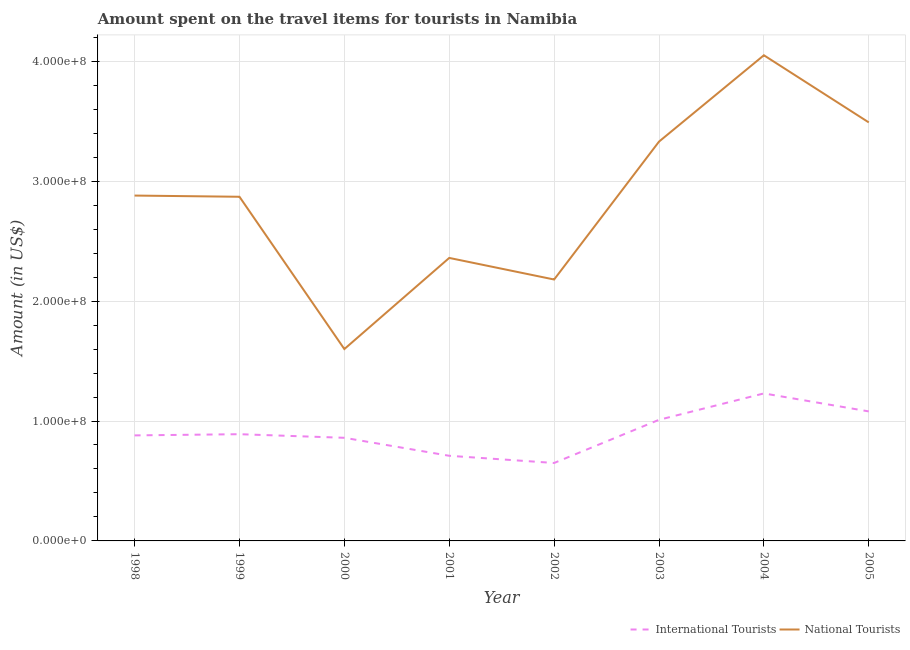How many different coloured lines are there?
Ensure brevity in your answer.  2. Does the line corresponding to amount spent on travel items of national tourists intersect with the line corresponding to amount spent on travel items of international tourists?
Make the answer very short. No. Is the number of lines equal to the number of legend labels?
Give a very brief answer. Yes. What is the amount spent on travel items of national tourists in 2004?
Provide a short and direct response. 4.05e+08. Across all years, what is the maximum amount spent on travel items of national tourists?
Keep it short and to the point. 4.05e+08. Across all years, what is the minimum amount spent on travel items of international tourists?
Keep it short and to the point. 6.50e+07. In which year was the amount spent on travel items of international tourists minimum?
Offer a very short reply. 2002. What is the total amount spent on travel items of international tourists in the graph?
Give a very brief answer. 7.31e+08. What is the difference between the amount spent on travel items of international tourists in 1999 and that in 2001?
Your answer should be very brief. 1.80e+07. What is the difference between the amount spent on travel items of international tourists in 2003 and the amount spent on travel items of national tourists in 2004?
Make the answer very short. -3.04e+08. What is the average amount spent on travel items of international tourists per year?
Keep it short and to the point. 9.14e+07. In the year 1998, what is the difference between the amount spent on travel items of national tourists and amount spent on travel items of international tourists?
Offer a terse response. 2.00e+08. In how many years, is the amount spent on travel items of national tourists greater than 40000000 US$?
Offer a terse response. 8. What is the ratio of the amount spent on travel items of international tourists in 2001 to that in 2002?
Your response must be concise. 1.09. Is the amount spent on travel items of international tourists in 2002 less than that in 2004?
Provide a succinct answer. Yes. What is the difference between the highest and the second highest amount spent on travel items of national tourists?
Provide a succinct answer. 5.60e+07. What is the difference between the highest and the lowest amount spent on travel items of national tourists?
Offer a terse response. 2.45e+08. In how many years, is the amount spent on travel items of international tourists greater than the average amount spent on travel items of international tourists taken over all years?
Keep it short and to the point. 3. Is the amount spent on travel items of national tourists strictly greater than the amount spent on travel items of international tourists over the years?
Provide a succinct answer. Yes. Is the amount spent on travel items of international tourists strictly less than the amount spent on travel items of national tourists over the years?
Offer a very short reply. Yes. How many years are there in the graph?
Keep it short and to the point. 8. What is the difference between two consecutive major ticks on the Y-axis?
Offer a terse response. 1.00e+08. How many legend labels are there?
Make the answer very short. 2. What is the title of the graph?
Keep it short and to the point. Amount spent on the travel items for tourists in Namibia. Does "Girls" appear as one of the legend labels in the graph?
Your answer should be compact. No. What is the label or title of the X-axis?
Your answer should be compact. Year. What is the Amount (in US$) in International Tourists in 1998?
Offer a very short reply. 8.80e+07. What is the Amount (in US$) in National Tourists in 1998?
Your response must be concise. 2.88e+08. What is the Amount (in US$) of International Tourists in 1999?
Provide a succinct answer. 8.90e+07. What is the Amount (in US$) in National Tourists in 1999?
Your answer should be compact. 2.87e+08. What is the Amount (in US$) of International Tourists in 2000?
Provide a short and direct response. 8.60e+07. What is the Amount (in US$) of National Tourists in 2000?
Your answer should be compact. 1.60e+08. What is the Amount (in US$) in International Tourists in 2001?
Your response must be concise. 7.10e+07. What is the Amount (in US$) in National Tourists in 2001?
Your response must be concise. 2.36e+08. What is the Amount (in US$) in International Tourists in 2002?
Offer a very short reply. 6.50e+07. What is the Amount (in US$) in National Tourists in 2002?
Your response must be concise. 2.18e+08. What is the Amount (in US$) in International Tourists in 2003?
Offer a very short reply. 1.01e+08. What is the Amount (in US$) in National Tourists in 2003?
Offer a very short reply. 3.33e+08. What is the Amount (in US$) in International Tourists in 2004?
Ensure brevity in your answer.  1.23e+08. What is the Amount (in US$) in National Tourists in 2004?
Keep it short and to the point. 4.05e+08. What is the Amount (in US$) of International Tourists in 2005?
Your response must be concise. 1.08e+08. What is the Amount (in US$) of National Tourists in 2005?
Offer a very short reply. 3.49e+08. Across all years, what is the maximum Amount (in US$) of International Tourists?
Provide a succinct answer. 1.23e+08. Across all years, what is the maximum Amount (in US$) of National Tourists?
Make the answer very short. 4.05e+08. Across all years, what is the minimum Amount (in US$) in International Tourists?
Your answer should be compact. 6.50e+07. Across all years, what is the minimum Amount (in US$) in National Tourists?
Make the answer very short. 1.60e+08. What is the total Amount (in US$) of International Tourists in the graph?
Offer a very short reply. 7.31e+08. What is the total Amount (in US$) of National Tourists in the graph?
Your response must be concise. 2.28e+09. What is the difference between the Amount (in US$) in International Tourists in 1998 and that in 2000?
Keep it short and to the point. 2.00e+06. What is the difference between the Amount (in US$) of National Tourists in 1998 and that in 2000?
Ensure brevity in your answer.  1.28e+08. What is the difference between the Amount (in US$) of International Tourists in 1998 and that in 2001?
Keep it short and to the point. 1.70e+07. What is the difference between the Amount (in US$) of National Tourists in 1998 and that in 2001?
Keep it short and to the point. 5.20e+07. What is the difference between the Amount (in US$) of International Tourists in 1998 and that in 2002?
Ensure brevity in your answer.  2.30e+07. What is the difference between the Amount (in US$) in National Tourists in 1998 and that in 2002?
Provide a succinct answer. 7.00e+07. What is the difference between the Amount (in US$) of International Tourists in 1998 and that in 2003?
Give a very brief answer. -1.30e+07. What is the difference between the Amount (in US$) of National Tourists in 1998 and that in 2003?
Your answer should be compact. -4.50e+07. What is the difference between the Amount (in US$) in International Tourists in 1998 and that in 2004?
Ensure brevity in your answer.  -3.50e+07. What is the difference between the Amount (in US$) of National Tourists in 1998 and that in 2004?
Offer a terse response. -1.17e+08. What is the difference between the Amount (in US$) of International Tourists in 1998 and that in 2005?
Your answer should be compact. -2.00e+07. What is the difference between the Amount (in US$) in National Tourists in 1998 and that in 2005?
Make the answer very short. -6.10e+07. What is the difference between the Amount (in US$) of International Tourists in 1999 and that in 2000?
Your answer should be compact. 3.00e+06. What is the difference between the Amount (in US$) in National Tourists in 1999 and that in 2000?
Provide a short and direct response. 1.27e+08. What is the difference between the Amount (in US$) in International Tourists in 1999 and that in 2001?
Provide a succinct answer. 1.80e+07. What is the difference between the Amount (in US$) in National Tourists in 1999 and that in 2001?
Make the answer very short. 5.10e+07. What is the difference between the Amount (in US$) in International Tourists in 1999 and that in 2002?
Keep it short and to the point. 2.40e+07. What is the difference between the Amount (in US$) in National Tourists in 1999 and that in 2002?
Give a very brief answer. 6.90e+07. What is the difference between the Amount (in US$) of International Tourists in 1999 and that in 2003?
Your answer should be very brief. -1.20e+07. What is the difference between the Amount (in US$) of National Tourists in 1999 and that in 2003?
Your response must be concise. -4.60e+07. What is the difference between the Amount (in US$) of International Tourists in 1999 and that in 2004?
Ensure brevity in your answer.  -3.40e+07. What is the difference between the Amount (in US$) of National Tourists in 1999 and that in 2004?
Ensure brevity in your answer.  -1.18e+08. What is the difference between the Amount (in US$) in International Tourists in 1999 and that in 2005?
Provide a succinct answer. -1.90e+07. What is the difference between the Amount (in US$) of National Tourists in 1999 and that in 2005?
Your response must be concise. -6.20e+07. What is the difference between the Amount (in US$) of International Tourists in 2000 and that in 2001?
Your answer should be compact. 1.50e+07. What is the difference between the Amount (in US$) in National Tourists in 2000 and that in 2001?
Keep it short and to the point. -7.60e+07. What is the difference between the Amount (in US$) in International Tourists in 2000 and that in 2002?
Your response must be concise. 2.10e+07. What is the difference between the Amount (in US$) of National Tourists in 2000 and that in 2002?
Keep it short and to the point. -5.80e+07. What is the difference between the Amount (in US$) in International Tourists in 2000 and that in 2003?
Give a very brief answer. -1.50e+07. What is the difference between the Amount (in US$) in National Tourists in 2000 and that in 2003?
Give a very brief answer. -1.73e+08. What is the difference between the Amount (in US$) of International Tourists in 2000 and that in 2004?
Keep it short and to the point. -3.70e+07. What is the difference between the Amount (in US$) in National Tourists in 2000 and that in 2004?
Keep it short and to the point. -2.45e+08. What is the difference between the Amount (in US$) in International Tourists in 2000 and that in 2005?
Give a very brief answer. -2.20e+07. What is the difference between the Amount (in US$) in National Tourists in 2000 and that in 2005?
Your answer should be compact. -1.89e+08. What is the difference between the Amount (in US$) in National Tourists in 2001 and that in 2002?
Offer a very short reply. 1.80e+07. What is the difference between the Amount (in US$) in International Tourists in 2001 and that in 2003?
Your answer should be very brief. -3.00e+07. What is the difference between the Amount (in US$) in National Tourists in 2001 and that in 2003?
Keep it short and to the point. -9.70e+07. What is the difference between the Amount (in US$) of International Tourists in 2001 and that in 2004?
Keep it short and to the point. -5.20e+07. What is the difference between the Amount (in US$) of National Tourists in 2001 and that in 2004?
Your answer should be very brief. -1.69e+08. What is the difference between the Amount (in US$) of International Tourists in 2001 and that in 2005?
Provide a succinct answer. -3.70e+07. What is the difference between the Amount (in US$) of National Tourists in 2001 and that in 2005?
Your answer should be very brief. -1.13e+08. What is the difference between the Amount (in US$) of International Tourists in 2002 and that in 2003?
Ensure brevity in your answer.  -3.60e+07. What is the difference between the Amount (in US$) in National Tourists in 2002 and that in 2003?
Your answer should be compact. -1.15e+08. What is the difference between the Amount (in US$) of International Tourists in 2002 and that in 2004?
Ensure brevity in your answer.  -5.80e+07. What is the difference between the Amount (in US$) in National Tourists in 2002 and that in 2004?
Ensure brevity in your answer.  -1.87e+08. What is the difference between the Amount (in US$) of International Tourists in 2002 and that in 2005?
Your answer should be very brief. -4.30e+07. What is the difference between the Amount (in US$) in National Tourists in 2002 and that in 2005?
Give a very brief answer. -1.31e+08. What is the difference between the Amount (in US$) in International Tourists in 2003 and that in 2004?
Provide a succinct answer. -2.20e+07. What is the difference between the Amount (in US$) in National Tourists in 2003 and that in 2004?
Your answer should be very brief. -7.20e+07. What is the difference between the Amount (in US$) of International Tourists in 2003 and that in 2005?
Keep it short and to the point. -7.00e+06. What is the difference between the Amount (in US$) in National Tourists in 2003 and that in 2005?
Provide a short and direct response. -1.60e+07. What is the difference between the Amount (in US$) in International Tourists in 2004 and that in 2005?
Provide a succinct answer. 1.50e+07. What is the difference between the Amount (in US$) in National Tourists in 2004 and that in 2005?
Give a very brief answer. 5.60e+07. What is the difference between the Amount (in US$) in International Tourists in 1998 and the Amount (in US$) in National Tourists in 1999?
Ensure brevity in your answer.  -1.99e+08. What is the difference between the Amount (in US$) in International Tourists in 1998 and the Amount (in US$) in National Tourists in 2000?
Provide a short and direct response. -7.20e+07. What is the difference between the Amount (in US$) of International Tourists in 1998 and the Amount (in US$) of National Tourists in 2001?
Your answer should be very brief. -1.48e+08. What is the difference between the Amount (in US$) of International Tourists in 1998 and the Amount (in US$) of National Tourists in 2002?
Provide a succinct answer. -1.30e+08. What is the difference between the Amount (in US$) of International Tourists in 1998 and the Amount (in US$) of National Tourists in 2003?
Offer a very short reply. -2.45e+08. What is the difference between the Amount (in US$) of International Tourists in 1998 and the Amount (in US$) of National Tourists in 2004?
Give a very brief answer. -3.17e+08. What is the difference between the Amount (in US$) in International Tourists in 1998 and the Amount (in US$) in National Tourists in 2005?
Ensure brevity in your answer.  -2.61e+08. What is the difference between the Amount (in US$) of International Tourists in 1999 and the Amount (in US$) of National Tourists in 2000?
Provide a succinct answer. -7.10e+07. What is the difference between the Amount (in US$) in International Tourists in 1999 and the Amount (in US$) in National Tourists in 2001?
Provide a succinct answer. -1.47e+08. What is the difference between the Amount (in US$) of International Tourists in 1999 and the Amount (in US$) of National Tourists in 2002?
Offer a very short reply. -1.29e+08. What is the difference between the Amount (in US$) in International Tourists in 1999 and the Amount (in US$) in National Tourists in 2003?
Ensure brevity in your answer.  -2.44e+08. What is the difference between the Amount (in US$) of International Tourists in 1999 and the Amount (in US$) of National Tourists in 2004?
Keep it short and to the point. -3.16e+08. What is the difference between the Amount (in US$) in International Tourists in 1999 and the Amount (in US$) in National Tourists in 2005?
Your answer should be very brief. -2.60e+08. What is the difference between the Amount (in US$) of International Tourists in 2000 and the Amount (in US$) of National Tourists in 2001?
Your answer should be compact. -1.50e+08. What is the difference between the Amount (in US$) in International Tourists in 2000 and the Amount (in US$) in National Tourists in 2002?
Make the answer very short. -1.32e+08. What is the difference between the Amount (in US$) of International Tourists in 2000 and the Amount (in US$) of National Tourists in 2003?
Provide a succinct answer. -2.47e+08. What is the difference between the Amount (in US$) of International Tourists in 2000 and the Amount (in US$) of National Tourists in 2004?
Keep it short and to the point. -3.19e+08. What is the difference between the Amount (in US$) in International Tourists in 2000 and the Amount (in US$) in National Tourists in 2005?
Provide a short and direct response. -2.63e+08. What is the difference between the Amount (in US$) in International Tourists in 2001 and the Amount (in US$) in National Tourists in 2002?
Give a very brief answer. -1.47e+08. What is the difference between the Amount (in US$) of International Tourists in 2001 and the Amount (in US$) of National Tourists in 2003?
Offer a very short reply. -2.62e+08. What is the difference between the Amount (in US$) in International Tourists in 2001 and the Amount (in US$) in National Tourists in 2004?
Your answer should be compact. -3.34e+08. What is the difference between the Amount (in US$) of International Tourists in 2001 and the Amount (in US$) of National Tourists in 2005?
Offer a terse response. -2.78e+08. What is the difference between the Amount (in US$) in International Tourists in 2002 and the Amount (in US$) in National Tourists in 2003?
Your answer should be very brief. -2.68e+08. What is the difference between the Amount (in US$) of International Tourists in 2002 and the Amount (in US$) of National Tourists in 2004?
Your answer should be compact. -3.40e+08. What is the difference between the Amount (in US$) of International Tourists in 2002 and the Amount (in US$) of National Tourists in 2005?
Make the answer very short. -2.84e+08. What is the difference between the Amount (in US$) of International Tourists in 2003 and the Amount (in US$) of National Tourists in 2004?
Offer a terse response. -3.04e+08. What is the difference between the Amount (in US$) of International Tourists in 2003 and the Amount (in US$) of National Tourists in 2005?
Offer a terse response. -2.48e+08. What is the difference between the Amount (in US$) in International Tourists in 2004 and the Amount (in US$) in National Tourists in 2005?
Your answer should be very brief. -2.26e+08. What is the average Amount (in US$) in International Tourists per year?
Offer a very short reply. 9.14e+07. What is the average Amount (in US$) of National Tourists per year?
Ensure brevity in your answer.  2.84e+08. In the year 1998, what is the difference between the Amount (in US$) in International Tourists and Amount (in US$) in National Tourists?
Your answer should be compact. -2.00e+08. In the year 1999, what is the difference between the Amount (in US$) of International Tourists and Amount (in US$) of National Tourists?
Your answer should be very brief. -1.98e+08. In the year 2000, what is the difference between the Amount (in US$) of International Tourists and Amount (in US$) of National Tourists?
Offer a terse response. -7.40e+07. In the year 2001, what is the difference between the Amount (in US$) in International Tourists and Amount (in US$) in National Tourists?
Provide a succinct answer. -1.65e+08. In the year 2002, what is the difference between the Amount (in US$) of International Tourists and Amount (in US$) of National Tourists?
Keep it short and to the point. -1.53e+08. In the year 2003, what is the difference between the Amount (in US$) of International Tourists and Amount (in US$) of National Tourists?
Provide a short and direct response. -2.32e+08. In the year 2004, what is the difference between the Amount (in US$) in International Tourists and Amount (in US$) in National Tourists?
Give a very brief answer. -2.82e+08. In the year 2005, what is the difference between the Amount (in US$) in International Tourists and Amount (in US$) in National Tourists?
Offer a very short reply. -2.41e+08. What is the ratio of the Amount (in US$) in International Tourists in 1998 to that in 1999?
Provide a short and direct response. 0.99. What is the ratio of the Amount (in US$) in International Tourists in 1998 to that in 2000?
Offer a very short reply. 1.02. What is the ratio of the Amount (in US$) of International Tourists in 1998 to that in 2001?
Make the answer very short. 1.24. What is the ratio of the Amount (in US$) in National Tourists in 1998 to that in 2001?
Ensure brevity in your answer.  1.22. What is the ratio of the Amount (in US$) of International Tourists in 1998 to that in 2002?
Give a very brief answer. 1.35. What is the ratio of the Amount (in US$) of National Tourists in 1998 to that in 2002?
Your answer should be very brief. 1.32. What is the ratio of the Amount (in US$) of International Tourists in 1998 to that in 2003?
Make the answer very short. 0.87. What is the ratio of the Amount (in US$) in National Tourists in 1998 to that in 2003?
Provide a succinct answer. 0.86. What is the ratio of the Amount (in US$) of International Tourists in 1998 to that in 2004?
Provide a succinct answer. 0.72. What is the ratio of the Amount (in US$) of National Tourists in 1998 to that in 2004?
Make the answer very short. 0.71. What is the ratio of the Amount (in US$) in International Tourists in 1998 to that in 2005?
Your response must be concise. 0.81. What is the ratio of the Amount (in US$) of National Tourists in 1998 to that in 2005?
Provide a succinct answer. 0.83. What is the ratio of the Amount (in US$) of International Tourists in 1999 to that in 2000?
Your response must be concise. 1.03. What is the ratio of the Amount (in US$) of National Tourists in 1999 to that in 2000?
Keep it short and to the point. 1.79. What is the ratio of the Amount (in US$) of International Tourists in 1999 to that in 2001?
Provide a succinct answer. 1.25. What is the ratio of the Amount (in US$) in National Tourists in 1999 to that in 2001?
Your answer should be very brief. 1.22. What is the ratio of the Amount (in US$) in International Tourists in 1999 to that in 2002?
Offer a very short reply. 1.37. What is the ratio of the Amount (in US$) of National Tourists in 1999 to that in 2002?
Offer a terse response. 1.32. What is the ratio of the Amount (in US$) in International Tourists in 1999 to that in 2003?
Ensure brevity in your answer.  0.88. What is the ratio of the Amount (in US$) of National Tourists in 1999 to that in 2003?
Provide a short and direct response. 0.86. What is the ratio of the Amount (in US$) in International Tourists in 1999 to that in 2004?
Offer a terse response. 0.72. What is the ratio of the Amount (in US$) of National Tourists in 1999 to that in 2004?
Offer a very short reply. 0.71. What is the ratio of the Amount (in US$) in International Tourists in 1999 to that in 2005?
Your answer should be compact. 0.82. What is the ratio of the Amount (in US$) of National Tourists in 1999 to that in 2005?
Your answer should be very brief. 0.82. What is the ratio of the Amount (in US$) in International Tourists in 2000 to that in 2001?
Offer a very short reply. 1.21. What is the ratio of the Amount (in US$) in National Tourists in 2000 to that in 2001?
Give a very brief answer. 0.68. What is the ratio of the Amount (in US$) in International Tourists in 2000 to that in 2002?
Your answer should be compact. 1.32. What is the ratio of the Amount (in US$) in National Tourists in 2000 to that in 2002?
Your response must be concise. 0.73. What is the ratio of the Amount (in US$) of International Tourists in 2000 to that in 2003?
Your answer should be compact. 0.85. What is the ratio of the Amount (in US$) in National Tourists in 2000 to that in 2003?
Your response must be concise. 0.48. What is the ratio of the Amount (in US$) of International Tourists in 2000 to that in 2004?
Keep it short and to the point. 0.7. What is the ratio of the Amount (in US$) of National Tourists in 2000 to that in 2004?
Provide a succinct answer. 0.4. What is the ratio of the Amount (in US$) of International Tourists in 2000 to that in 2005?
Offer a terse response. 0.8. What is the ratio of the Amount (in US$) in National Tourists in 2000 to that in 2005?
Make the answer very short. 0.46. What is the ratio of the Amount (in US$) in International Tourists in 2001 to that in 2002?
Offer a terse response. 1.09. What is the ratio of the Amount (in US$) of National Tourists in 2001 to that in 2002?
Provide a succinct answer. 1.08. What is the ratio of the Amount (in US$) in International Tourists in 2001 to that in 2003?
Your response must be concise. 0.7. What is the ratio of the Amount (in US$) of National Tourists in 2001 to that in 2003?
Provide a short and direct response. 0.71. What is the ratio of the Amount (in US$) in International Tourists in 2001 to that in 2004?
Ensure brevity in your answer.  0.58. What is the ratio of the Amount (in US$) of National Tourists in 2001 to that in 2004?
Offer a terse response. 0.58. What is the ratio of the Amount (in US$) of International Tourists in 2001 to that in 2005?
Ensure brevity in your answer.  0.66. What is the ratio of the Amount (in US$) in National Tourists in 2001 to that in 2005?
Your response must be concise. 0.68. What is the ratio of the Amount (in US$) in International Tourists in 2002 to that in 2003?
Offer a very short reply. 0.64. What is the ratio of the Amount (in US$) of National Tourists in 2002 to that in 2003?
Your response must be concise. 0.65. What is the ratio of the Amount (in US$) of International Tourists in 2002 to that in 2004?
Your answer should be very brief. 0.53. What is the ratio of the Amount (in US$) of National Tourists in 2002 to that in 2004?
Your response must be concise. 0.54. What is the ratio of the Amount (in US$) in International Tourists in 2002 to that in 2005?
Your answer should be compact. 0.6. What is the ratio of the Amount (in US$) in National Tourists in 2002 to that in 2005?
Provide a succinct answer. 0.62. What is the ratio of the Amount (in US$) in International Tourists in 2003 to that in 2004?
Your answer should be very brief. 0.82. What is the ratio of the Amount (in US$) in National Tourists in 2003 to that in 2004?
Keep it short and to the point. 0.82. What is the ratio of the Amount (in US$) of International Tourists in 2003 to that in 2005?
Offer a terse response. 0.94. What is the ratio of the Amount (in US$) of National Tourists in 2003 to that in 2005?
Ensure brevity in your answer.  0.95. What is the ratio of the Amount (in US$) of International Tourists in 2004 to that in 2005?
Offer a terse response. 1.14. What is the ratio of the Amount (in US$) in National Tourists in 2004 to that in 2005?
Provide a short and direct response. 1.16. What is the difference between the highest and the second highest Amount (in US$) of International Tourists?
Ensure brevity in your answer.  1.50e+07. What is the difference between the highest and the second highest Amount (in US$) of National Tourists?
Provide a succinct answer. 5.60e+07. What is the difference between the highest and the lowest Amount (in US$) of International Tourists?
Make the answer very short. 5.80e+07. What is the difference between the highest and the lowest Amount (in US$) in National Tourists?
Provide a short and direct response. 2.45e+08. 